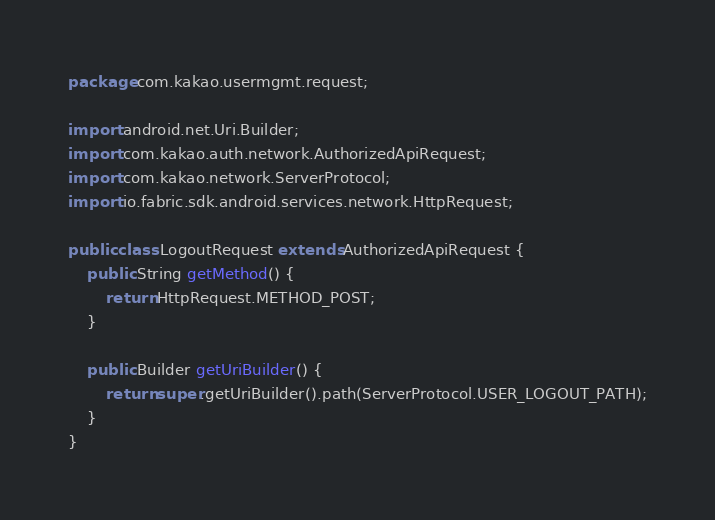<code> <loc_0><loc_0><loc_500><loc_500><_Java_>package com.kakao.usermgmt.request;

import android.net.Uri.Builder;
import com.kakao.auth.network.AuthorizedApiRequest;
import com.kakao.network.ServerProtocol;
import io.fabric.sdk.android.services.network.HttpRequest;

public class LogoutRequest extends AuthorizedApiRequest {
    public String getMethod() {
        return HttpRequest.METHOD_POST;
    }

    public Builder getUriBuilder() {
        return super.getUriBuilder().path(ServerProtocol.USER_LOGOUT_PATH);
    }
}
</code> 